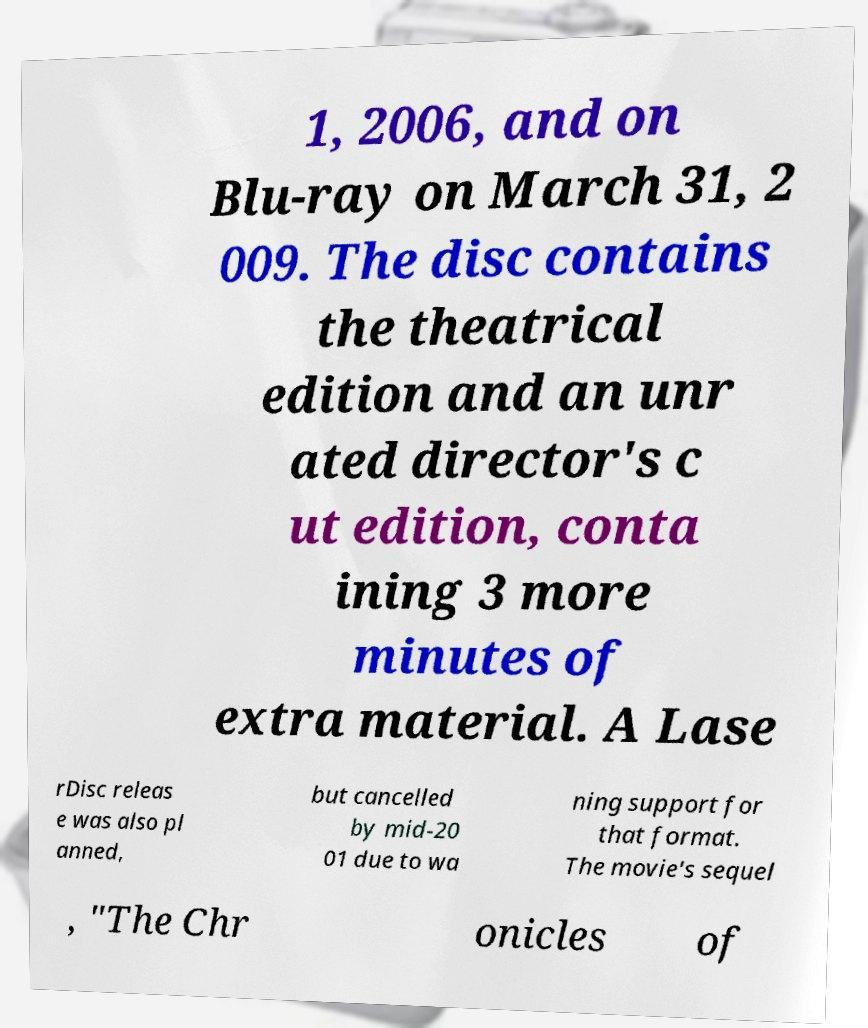Please identify and transcribe the text found in this image. 1, 2006, and on Blu-ray on March 31, 2 009. The disc contains the theatrical edition and an unr ated director's c ut edition, conta ining 3 more minutes of extra material. A Lase rDisc releas e was also pl anned, but cancelled by mid-20 01 due to wa ning support for that format. The movie's sequel , "The Chr onicles of 